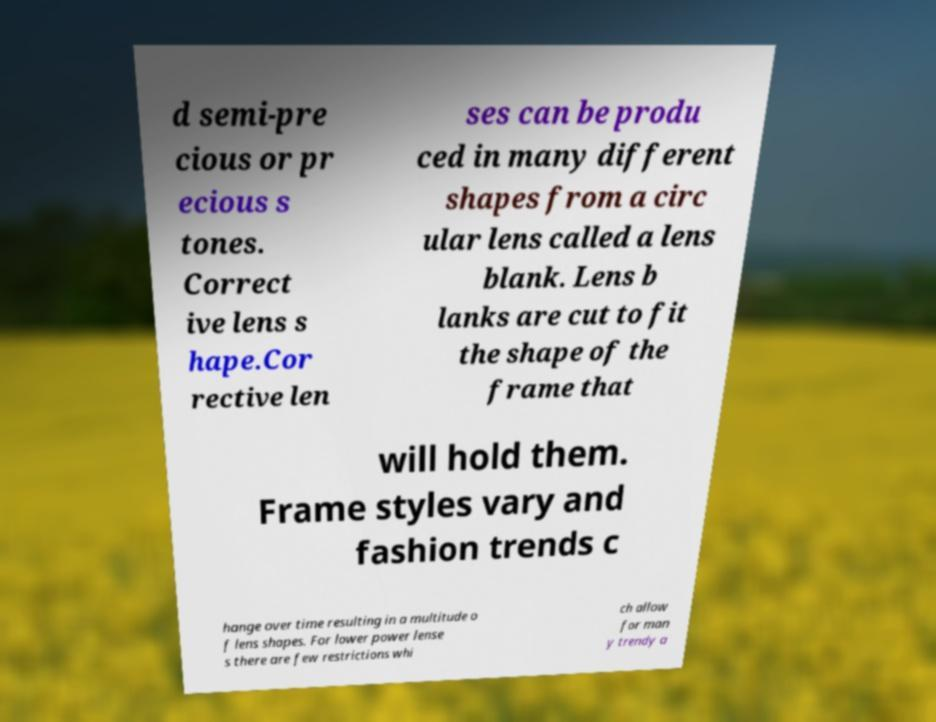Could you extract and type out the text from this image? d semi-pre cious or pr ecious s tones. Correct ive lens s hape.Cor rective len ses can be produ ced in many different shapes from a circ ular lens called a lens blank. Lens b lanks are cut to fit the shape of the frame that will hold them. Frame styles vary and fashion trends c hange over time resulting in a multitude o f lens shapes. For lower power lense s there are few restrictions whi ch allow for man y trendy a 